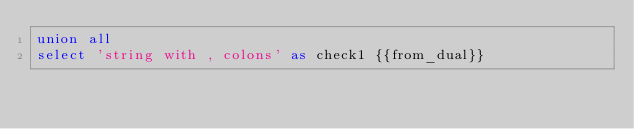Convert code to text. <code><loc_0><loc_0><loc_500><loc_500><_SQL_>union all
select 'string with , colons' as check1 {{from_dual}}
</code> 